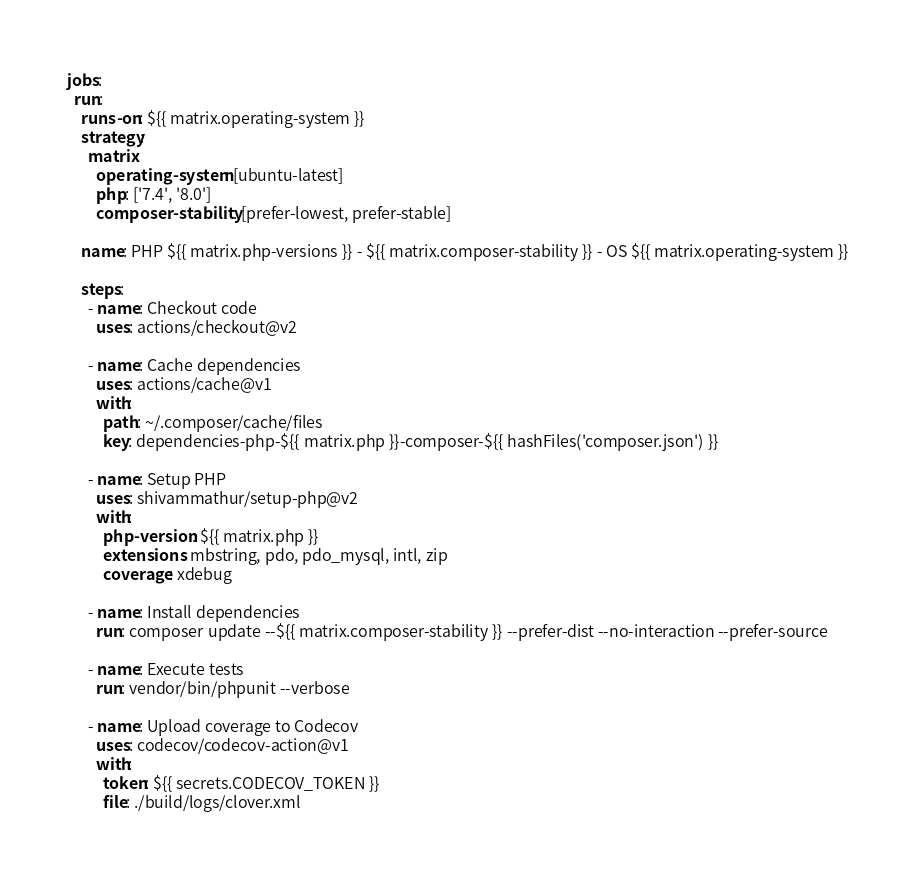<code> <loc_0><loc_0><loc_500><loc_500><_YAML_>jobs:
  run:
    runs-on: ${{ matrix.operating-system }}
    strategy:
      matrix:
        operating-system: [ubuntu-latest]
        php: ['7.4', '8.0']
        composer-stability: [prefer-lowest, prefer-stable]

    name: PHP ${{ matrix.php-versions }} - ${{ matrix.composer-stability }} - OS ${{ matrix.operating-system }}

    steps:
      - name: Checkout code
        uses: actions/checkout@v2

      - name: Cache dependencies
        uses: actions/cache@v1
        with:
          path: ~/.composer/cache/files
          key: dependencies-php-${{ matrix.php }}-composer-${{ hashFiles('composer.json') }}

      - name: Setup PHP
        uses: shivammathur/setup-php@v2
        with:
          php-version: ${{ matrix.php }}
          extensions: mbstring, pdo, pdo_mysql, intl, zip
          coverage: xdebug

      - name: Install dependencies
        run: composer update --${{ matrix.composer-stability }} --prefer-dist --no-interaction --prefer-source

      - name: Execute tests
        run: vendor/bin/phpunit --verbose

      - name: Upload coverage to Codecov
        uses: codecov/codecov-action@v1
        with:
          token: ${{ secrets.CODECOV_TOKEN }}
          file: ./build/logs/clover.xml
</code> 